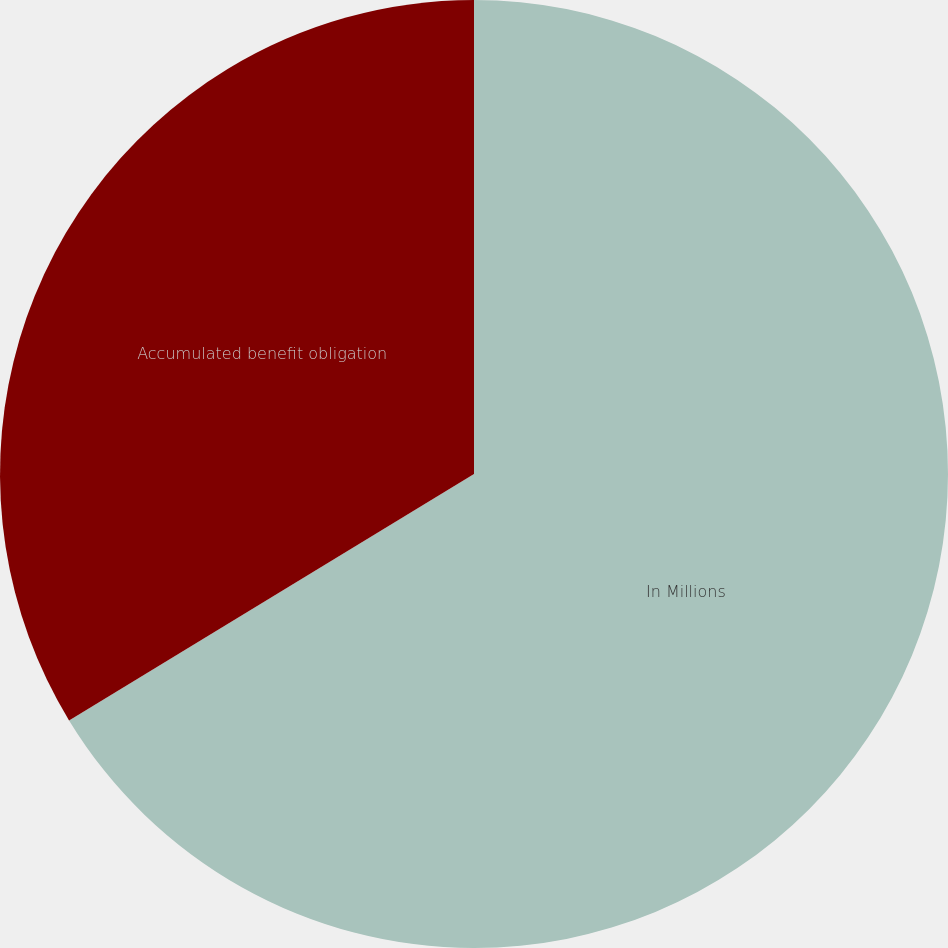<chart> <loc_0><loc_0><loc_500><loc_500><pie_chart><fcel>In Millions<fcel>Accumulated benefit obligation<nl><fcel>66.3%<fcel>33.7%<nl></chart> 